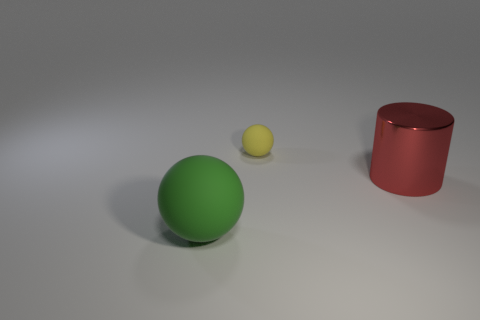Are there any other things that have the same material as the big red cylinder?
Ensure brevity in your answer.  No. What is the big object on the right side of the big ball made of?
Provide a succinct answer. Metal. There is a rubber object that is in front of the rubber object that is right of the rubber object that is in front of the metallic cylinder; what shape is it?
Your answer should be very brief. Sphere. Does the red metal cylinder have the same size as the yellow matte ball?
Your answer should be very brief. No. How many things are green things or yellow rubber objects right of the green sphere?
Offer a terse response. 2. How many objects are matte things in front of the red metallic cylinder or balls that are in front of the small matte ball?
Give a very brief answer. 1. There is a small yellow rubber thing; are there any red cylinders on the left side of it?
Make the answer very short. No. There is a thing that is to the left of the thing behind the large thing that is to the right of the large sphere; what color is it?
Provide a short and direct response. Green. Is the shape of the large rubber thing the same as the yellow thing?
Give a very brief answer. Yes. What color is the ball that is the same material as the small object?
Provide a short and direct response. Green. 